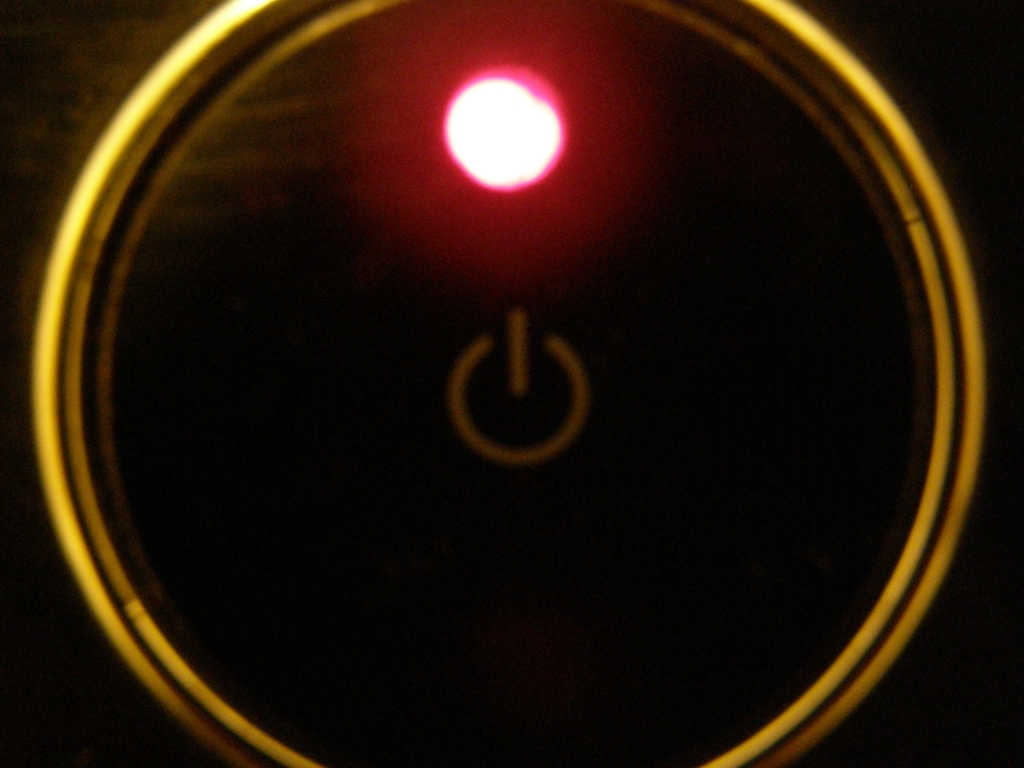What might this button be used for? This type of button, illuminated by what appears to be an LED light, is commonly used as a power switch on electronic devices. Its prominent placement and glowing light serve as an intuitive signal for users to turn the device on or off. 